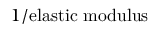<formula> <loc_0><loc_0><loc_500><loc_500>1 / { e l a s t i c m o d u l u s }</formula> 